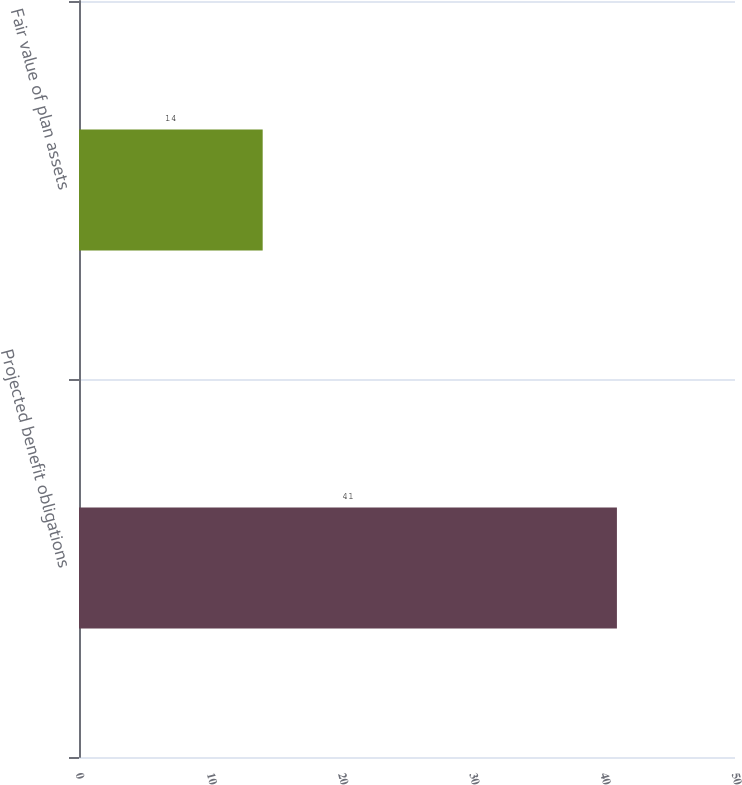Convert chart. <chart><loc_0><loc_0><loc_500><loc_500><bar_chart><fcel>Projected benefit obligations<fcel>Fair value of plan assets<nl><fcel>41<fcel>14<nl></chart> 